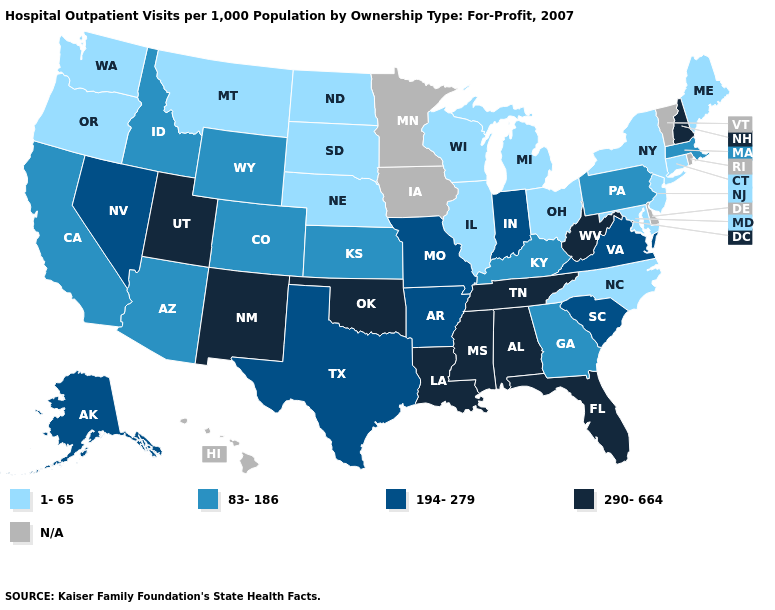Name the states that have a value in the range N/A?
Answer briefly. Delaware, Hawaii, Iowa, Minnesota, Rhode Island, Vermont. Name the states that have a value in the range 194-279?
Answer briefly. Alaska, Arkansas, Indiana, Missouri, Nevada, South Carolina, Texas, Virginia. Does California have the lowest value in the USA?
Write a very short answer. No. Does the map have missing data?
Be succinct. Yes. Does Connecticut have the highest value in the Northeast?
Give a very brief answer. No. What is the lowest value in the USA?
Quick response, please. 1-65. Among the states that border North Dakota , which have the lowest value?
Give a very brief answer. Montana, South Dakota. What is the lowest value in the South?
Be succinct. 1-65. Among the states that border Alabama , which have the highest value?
Quick response, please. Florida, Mississippi, Tennessee. What is the value of New Hampshire?
Answer briefly. 290-664. Among the states that border Texas , does Arkansas have the lowest value?
Concise answer only. Yes. What is the value of Pennsylvania?
Quick response, please. 83-186. Does the map have missing data?
Answer briefly. Yes. 